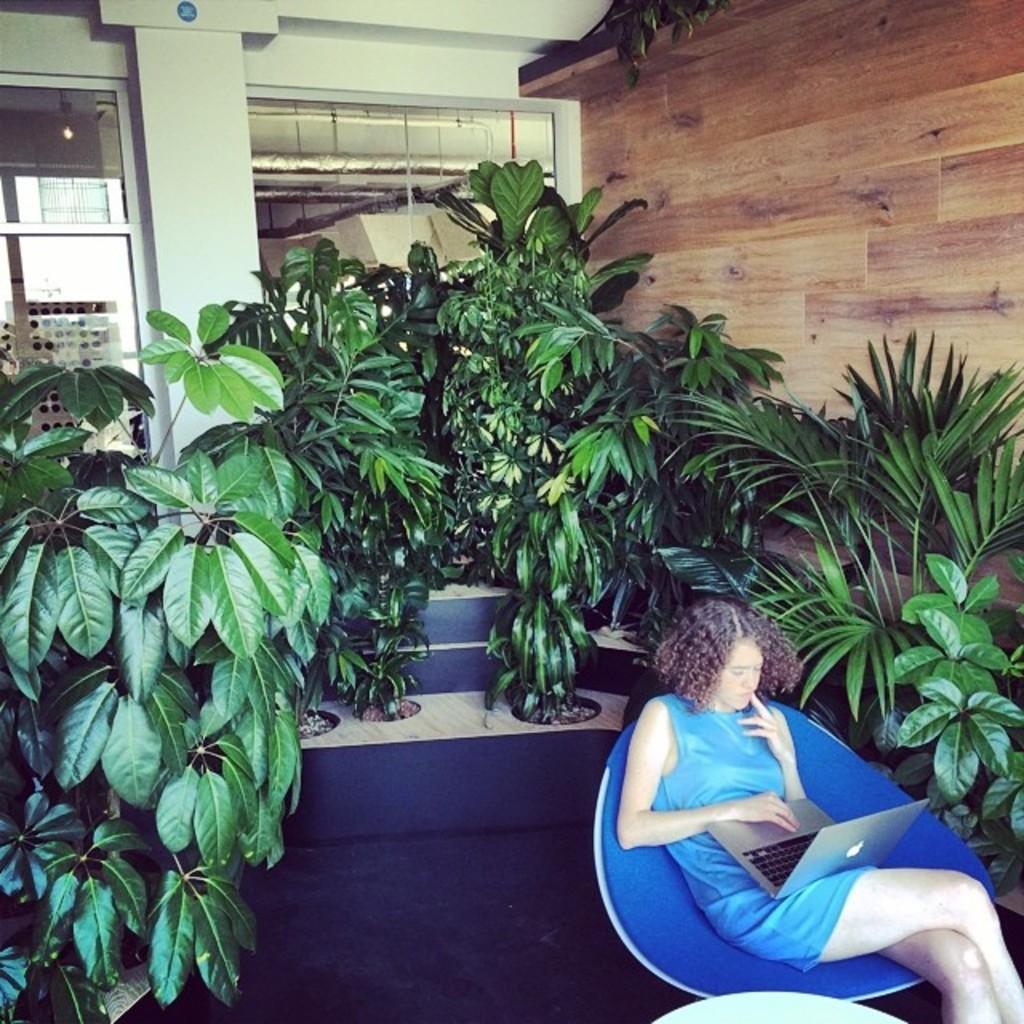Describe this image in one or two sentences. In this image we can see a woman sitting on a chair and looking at a laptop. In the center of the image we can see some plants. In the background, we can see windows, a pillar and the wall. 